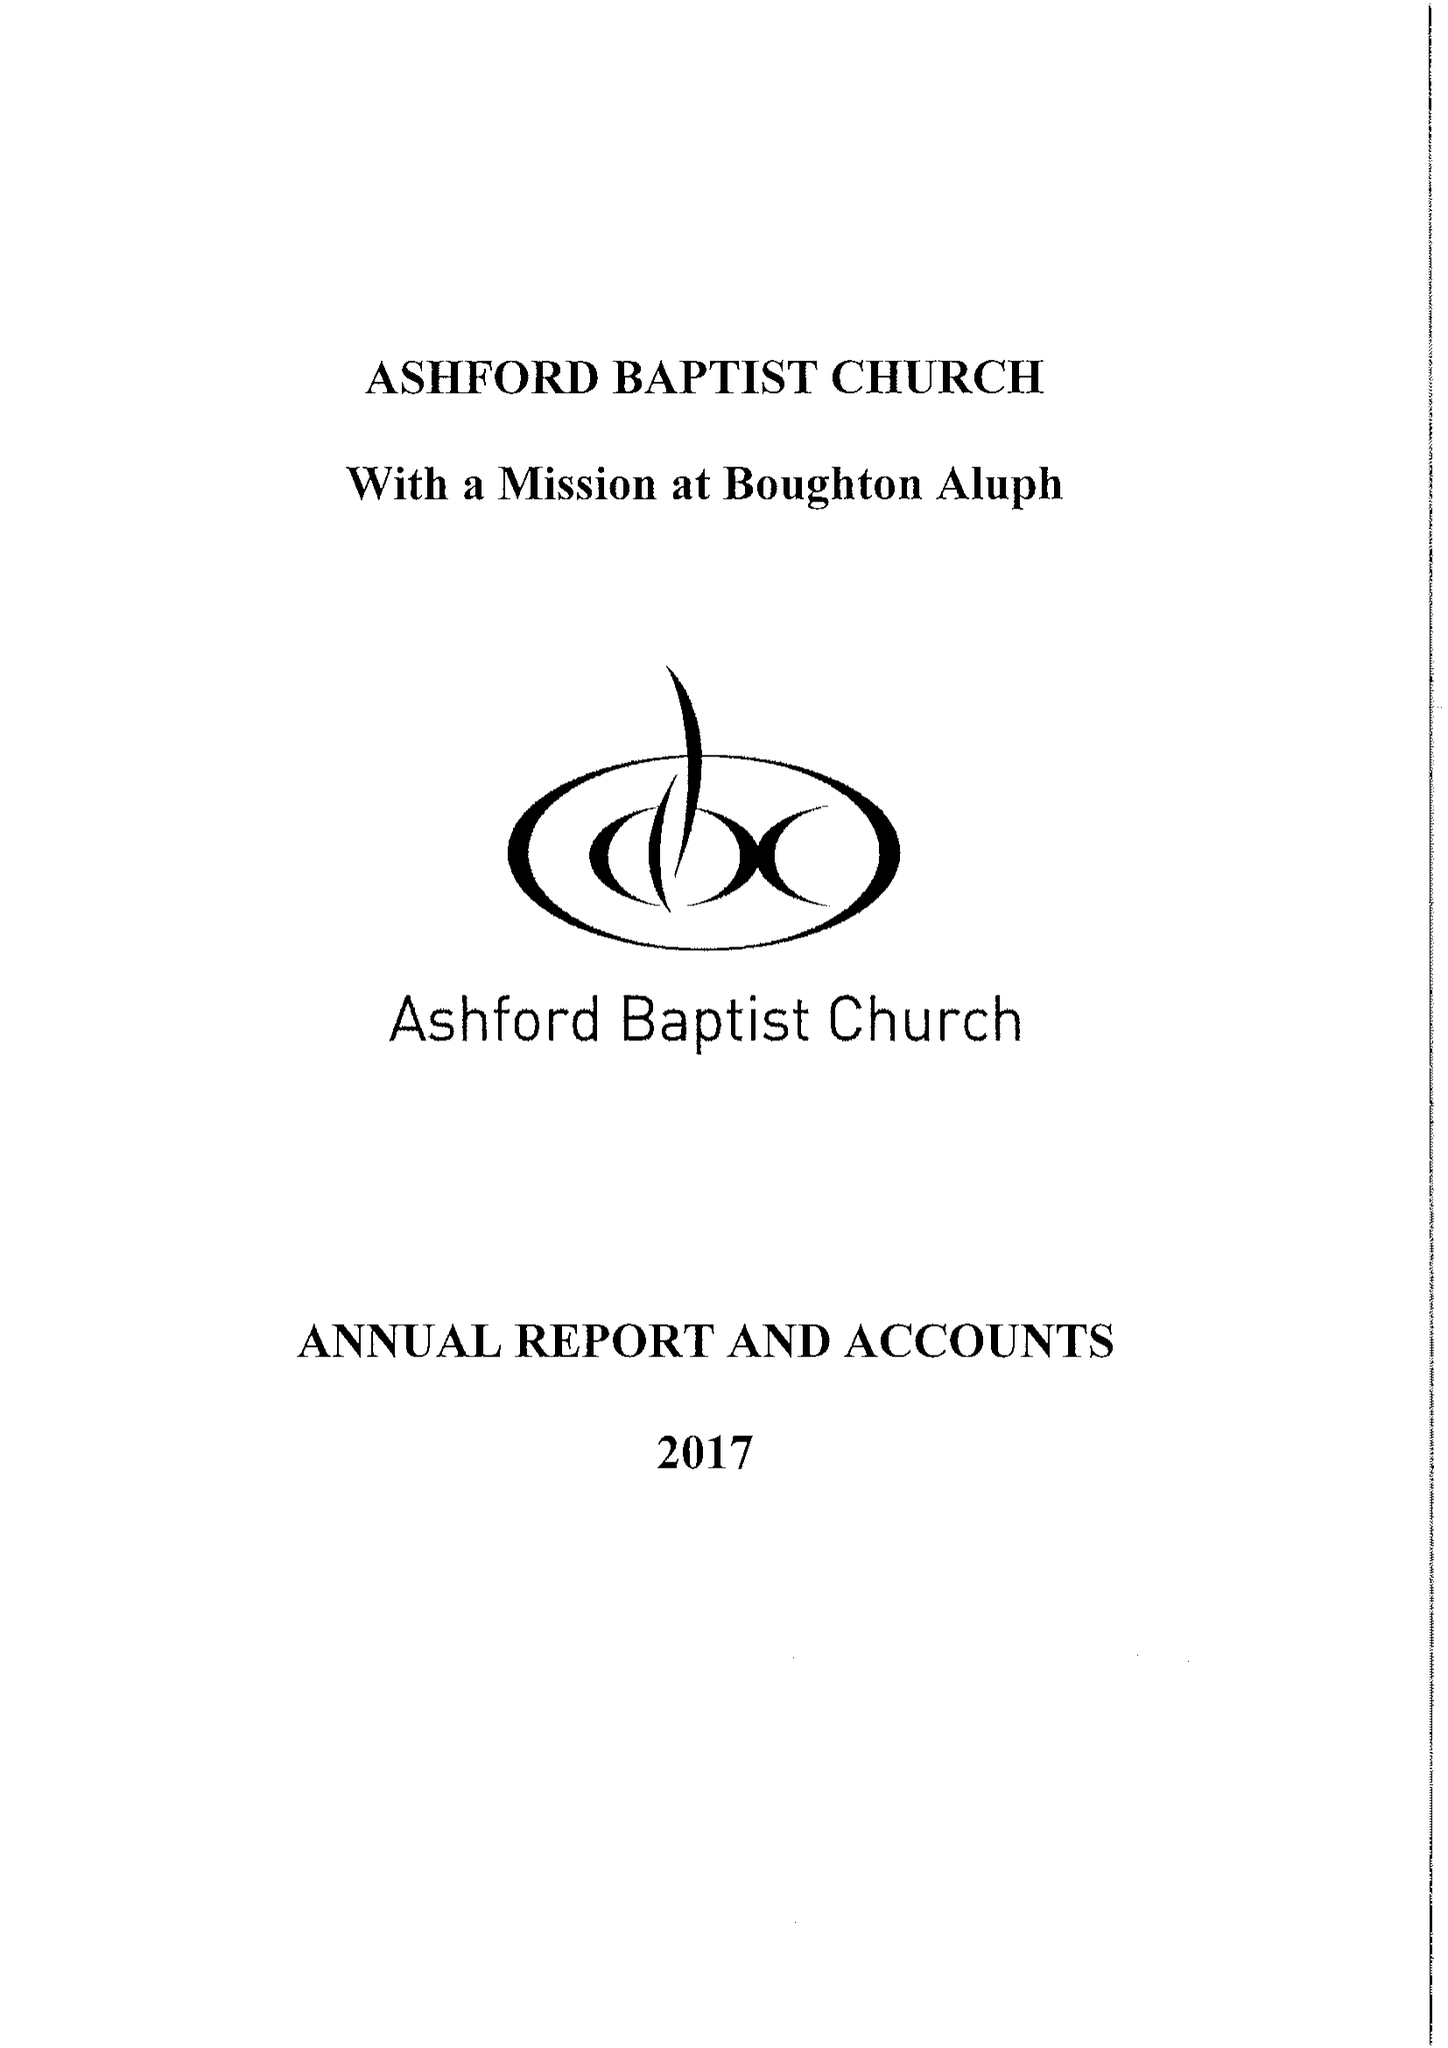What is the value for the spending_annually_in_british_pounds?
Answer the question using a single word or phrase. 157066.00 